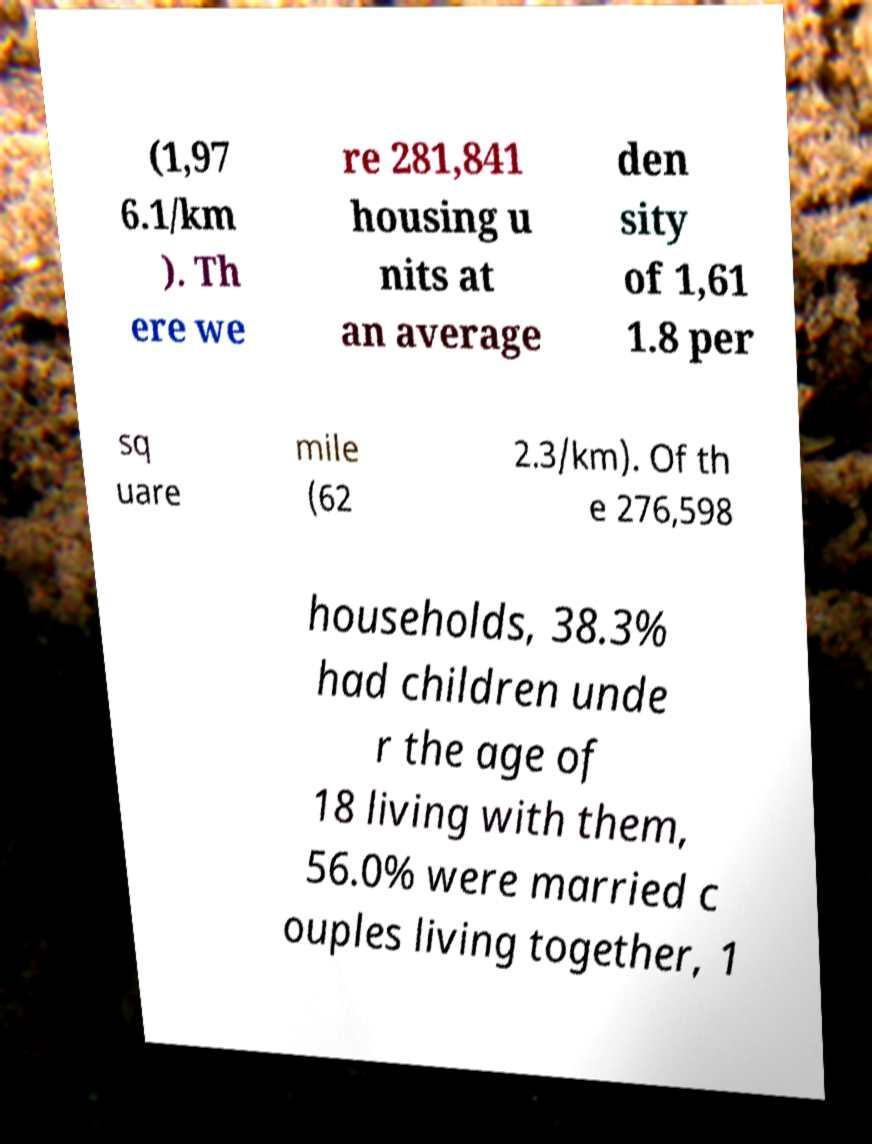Could you extract and type out the text from this image? (1,97 6.1/km ). Th ere we re 281,841 housing u nits at an average den sity of 1,61 1.8 per sq uare mile (62 2.3/km). Of th e 276,598 households, 38.3% had children unde r the age of 18 living with them, 56.0% were married c ouples living together, 1 